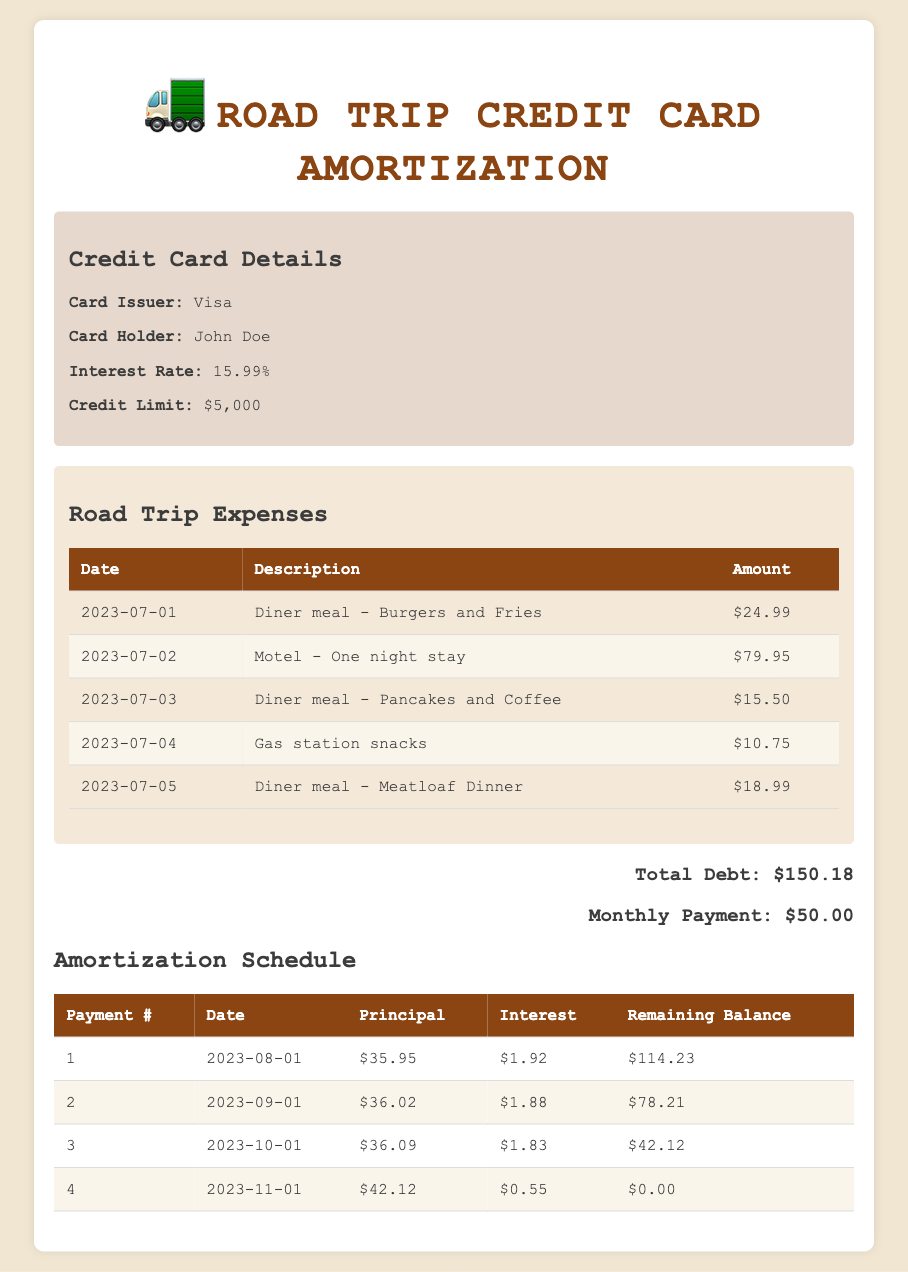What is the total amount of credit card debt incurred for road trip expenses? The total credit card debt is shown in the table as $150.18.
Answer: 150.18 How much was spent on lodging during the road trip? There was a single lodging expense listed for the motel, which costs $79.95.
Answer: 79.95 What is the total amount spent on meals at the diner? The diner meals attributable to the road trip are $24.99, $15.50, and $18.99. Adding these gives $24.99 + $15.50 + $18.99 = $59.48.
Answer: 59.48 What was the remaining balance after the first payment? The remaining balance after the first payment, which is indicated in the table, is $114.23.
Answer: 114.23 Does the total debt exceed $100? The total debt of $150.18 is greater than $100.
Answer: Yes How much interest was paid over the entire repayment period? The total interest payments over four months are $1.92 + $1.88 + $1.83 + $0.55 = $6.18.
Answer: 6.18 What was the principal payment for the last payment? The principal payment for the final payment is listed as $42.12 in the amortization schedule.
Answer: 42.12 How many payments are made until the debt is fully paid off? The amortization schedule indicates that there are a total of four payments made to fully pay off the debt.
Answer: 4 What is the average principal payment across all payments? The principal payments listed are $35.95, $36.02, $36.09, and $42.12. The sum is $150.18, and since there are 4 payments, the average principal payment is $150.18 / 4 = $37.55.
Answer: 37.55 